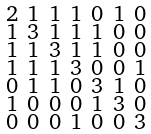<formula> <loc_0><loc_0><loc_500><loc_500>\begin{smallmatrix} 2 & 1 & 1 & 1 & 0 & 1 & 0 \\ 1 & 3 & 1 & 1 & 1 & 0 & 0 \\ 1 & 1 & 3 & 1 & 1 & 0 & 0 \\ 1 & 1 & 1 & 3 & 0 & 0 & 1 \\ 0 & 1 & 1 & 0 & 3 & 1 & 0 \\ 1 & 0 & 0 & 0 & 1 & 3 & 0 \\ 0 & 0 & 0 & 1 & 0 & 0 & 3 \end{smallmatrix}</formula> 